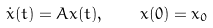<formula> <loc_0><loc_0><loc_500><loc_500>\dot { x } ( t ) = A x ( t ) , \quad x ( 0 ) = x _ { 0 }</formula> 